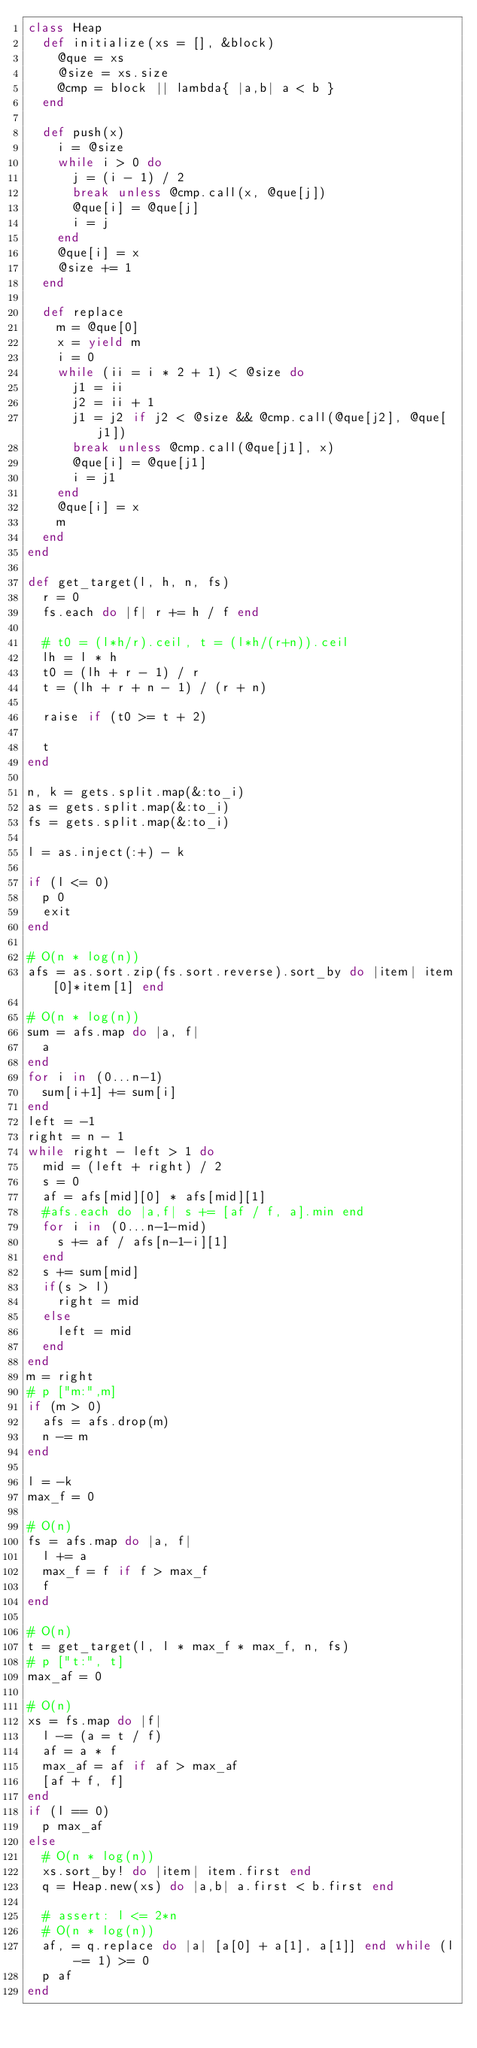<code> <loc_0><loc_0><loc_500><loc_500><_Ruby_>class Heap
  def initialize(xs = [], &block)
    @que = xs
    @size = xs.size
    @cmp = block || lambda{ |a,b| a < b }
  end

  def push(x)
    i = @size
    while i > 0 do
      j = (i - 1) / 2
      break unless @cmp.call(x, @que[j])
      @que[i] = @que[j]
      i = j
    end
    @que[i] = x
    @size += 1
  end

  def replace
    m = @que[0]
    x = yield m
    i = 0
    while (ii = i * 2 + 1) < @size do
      j1 = ii
      j2 = ii + 1
      j1 = j2 if j2 < @size && @cmp.call(@que[j2], @que[j1])
      break unless @cmp.call(@que[j1], x)
      @que[i] = @que[j1]
      i = j1
    end
    @que[i] = x
    m
  end
end

def get_target(l, h, n, fs)
  r = 0
  fs.each do |f| r += h / f end

  # t0 = (l*h/r).ceil, t = (l*h/(r+n)).ceil
  lh = l * h
  t0 = (lh + r - 1) / r
  t = (lh + r + n - 1) / (r + n)

  raise if (t0 >= t + 2)

  t
end

n, k = gets.split.map(&:to_i)
as = gets.split.map(&:to_i)
fs = gets.split.map(&:to_i)
 
l = as.inject(:+) - k

if (l <= 0)
  p 0
  exit
end

# O(n * log(n))
afs = as.sort.zip(fs.sort.reverse).sort_by do |item| item[0]*item[1] end

# O(n * log(n))
sum = afs.map do |a, f|
  a
end
for i in (0...n-1)
  sum[i+1] += sum[i]
end
left = -1
right = n - 1
while right - left > 1 do
  mid = (left + right) / 2
  s = 0
  af = afs[mid][0] * afs[mid][1]
  #afs.each do |a,f| s += [af / f, a].min end
  for i in (0...n-1-mid)
    s += af / afs[n-1-i][1]
  end
  s += sum[mid]
  if(s > l)
    right = mid
  else
    left = mid
  end
end
m = right
# p ["m:",m]
if (m > 0)
  afs = afs.drop(m)
  n -= m
end
 
l = -k
max_f = 0
 
# O(n)
fs = afs.map do |a, f|
  l += a
  max_f = f if f > max_f
  f
end
 
# O(n)
t = get_target(l, l * max_f * max_f, n, fs)
# p ["t:", t]
max_af = 0
 
# O(n)
xs = fs.map do |f|
  l -= (a = t / f)
  af = a * f
  max_af = af if af > max_af
  [af + f, f]
end
if (l == 0)
  p max_af
else
  # O(n * log(n))
  xs.sort_by! do |item| item.first end
  q = Heap.new(xs) do |a,b| a.first < b.first end
 
  # assert: l <= 2*n
  # O(n * log(n))
  af, = q.replace do |a| [a[0] + a[1], a[1]] end while (l -= 1) >= 0
  p af
end

</code> 